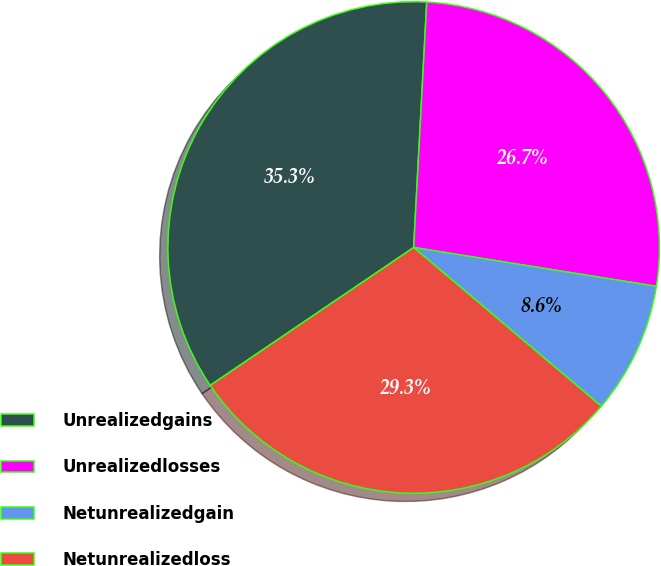<chart> <loc_0><loc_0><loc_500><loc_500><pie_chart><fcel>Unrealizedgains<fcel>Unrealizedlosses<fcel>Netunrealizedgain<fcel>Netunrealizedloss<nl><fcel>35.33%<fcel>26.68%<fcel>8.65%<fcel>29.34%<nl></chart> 